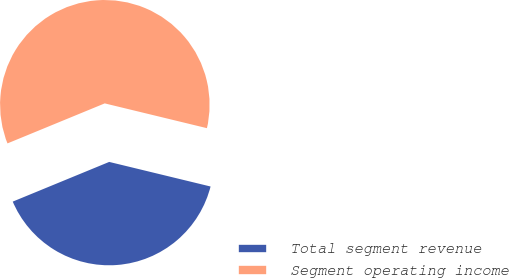<chart> <loc_0><loc_0><loc_500><loc_500><pie_chart><fcel>Total segment revenue<fcel>Segment operating income<nl><fcel>40.0%<fcel>60.0%<nl></chart> 